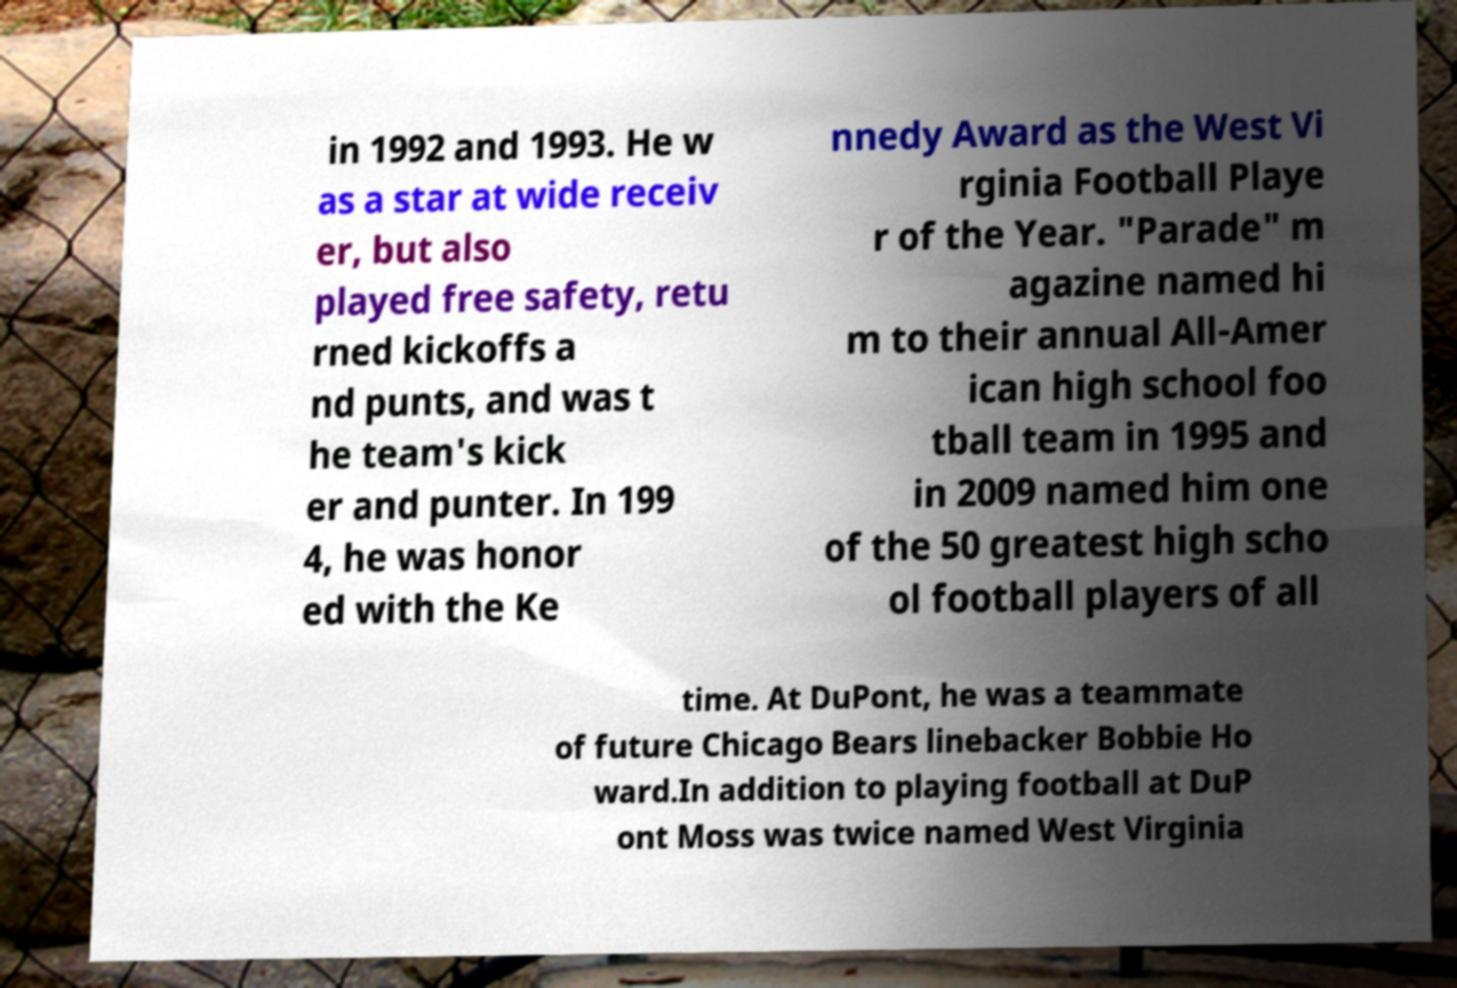For documentation purposes, I need the text within this image transcribed. Could you provide that? in 1992 and 1993. He w as a star at wide receiv er, but also played free safety, retu rned kickoffs a nd punts, and was t he team's kick er and punter. In 199 4, he was honor ed with the Ke nnedy Award as the West Vi rginia Football Playe r of the Year. "Parade" m agazine named hi m to their annual All-Amer ican high school foo tball team in 1995 and in 2009 named him one of the 50 greatest high scho ol football players of all time. At DuPont, he was a teammate of future Chicago Bears linebacker Bobbie Ho ward.In addition to playing football at DuP ont Moss was twice named West Virginia 